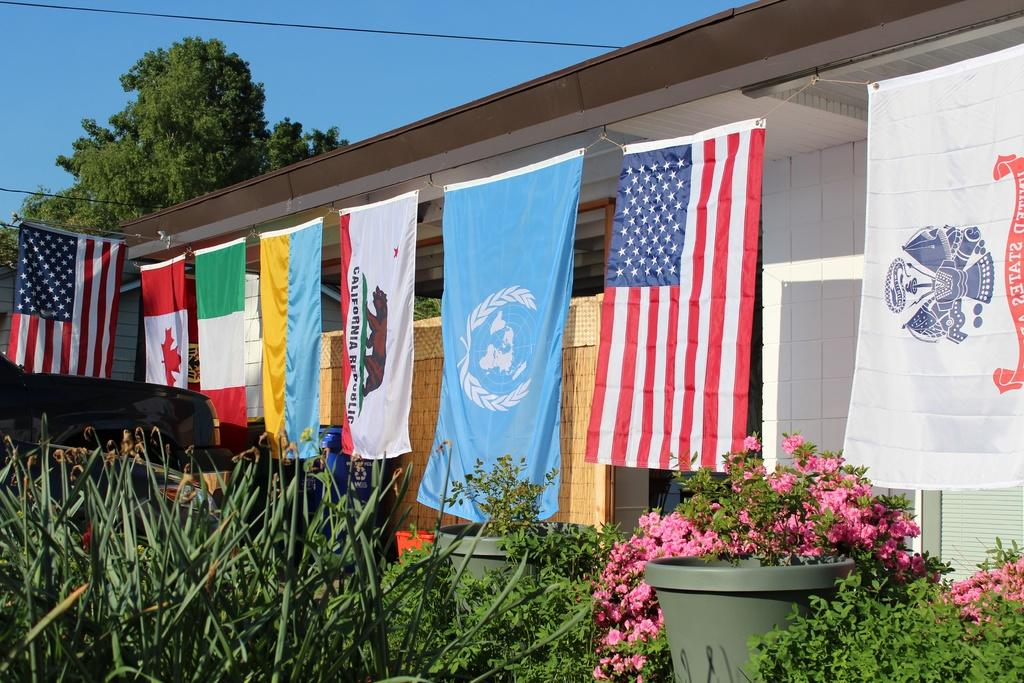What types of living organisms can be seen in the image? Plants and flowers are visible in the image. What type of structure is present in the image? There is a house in the image. What decorative elements can be seen in the image? There are flags in the image. What natural element is present in the image? There is a tree in the image. What is visible in the background of the image? The sky is visible in the background of the image. How many students are present in the image, and what type of knot are they learning to tie? There are no students or knot-tying activities present in the image. 